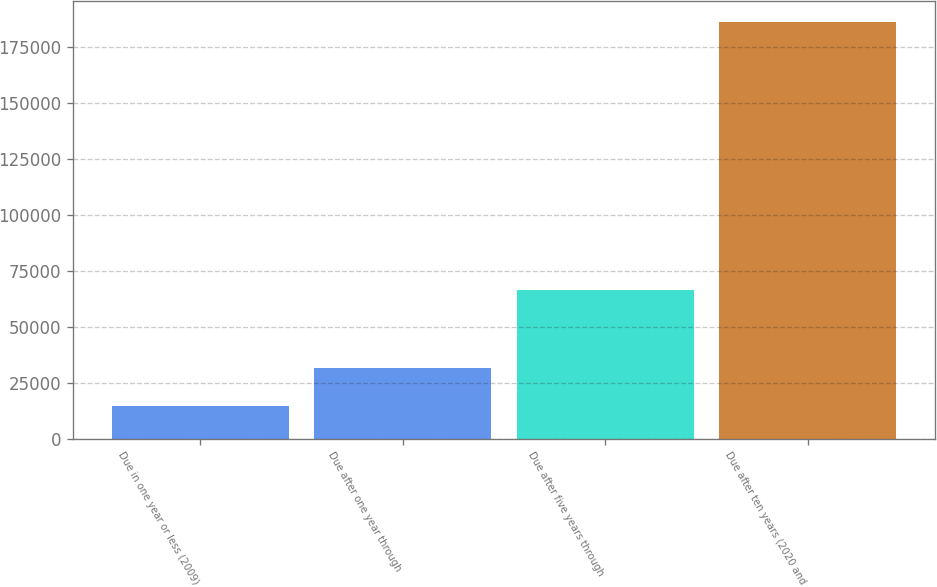Convert chart. <chart><loc_0><loc_0><loc_500><loc_500><bar_chart><fcel>Due in one year or less (2009)<fcel>Due after one year through<fcel>Due after five years through<fcel>Due after ten years (2020 and<nl><fcel>14535<fcel>31694.6<fcel>66515<fcel>186131<nl></chart> 